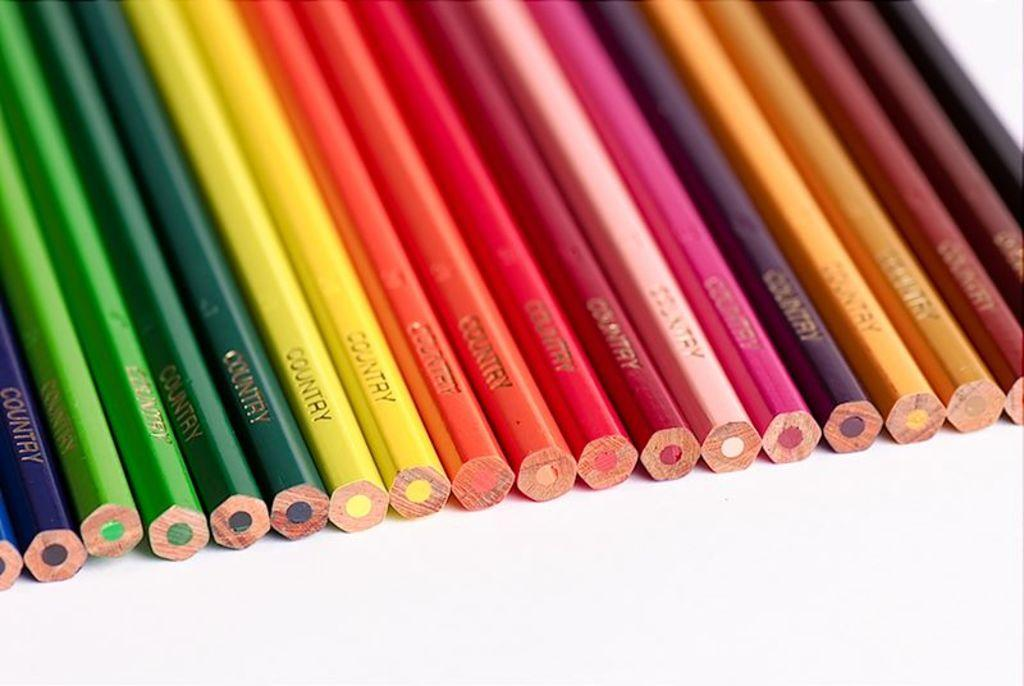Provide a one-sentence caption for the provided image. a few pencils with the word country on it. 